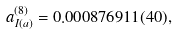<formula> <loc_0><loc_0><loc_500><loc_500>a _ { I ( a ) } ^ { ( 8 ) } = 0 . 0 0 0 8 7 6 9 1 1 ( 4 0 ) ,</formula> 